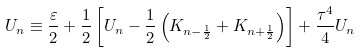<formula> <loc_0><loc_0><loc_500><loc_500>U _ { n } \equiv \frac { \varepsilon } { 2 } + \frac { 1 } { 2 } \left [ U _ { n } - \frac { 1 } { 2 } \left ( K _ { n - \frac { 1 } { 2 } } + K _ { n + \frac { 1 } { 2 } } \right ) \right ] + \frac { \tau ^ { 4 } } 4 U _ { n }</formula> 